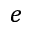Convert formula to latex. <formula><loc_0><loc_0><loc_500><loc_500>e</formula> 